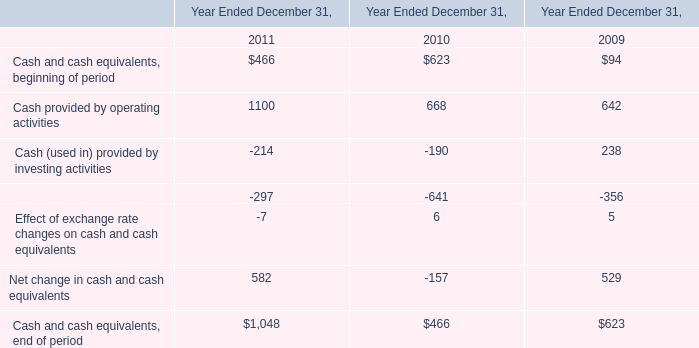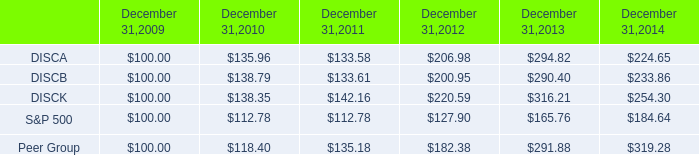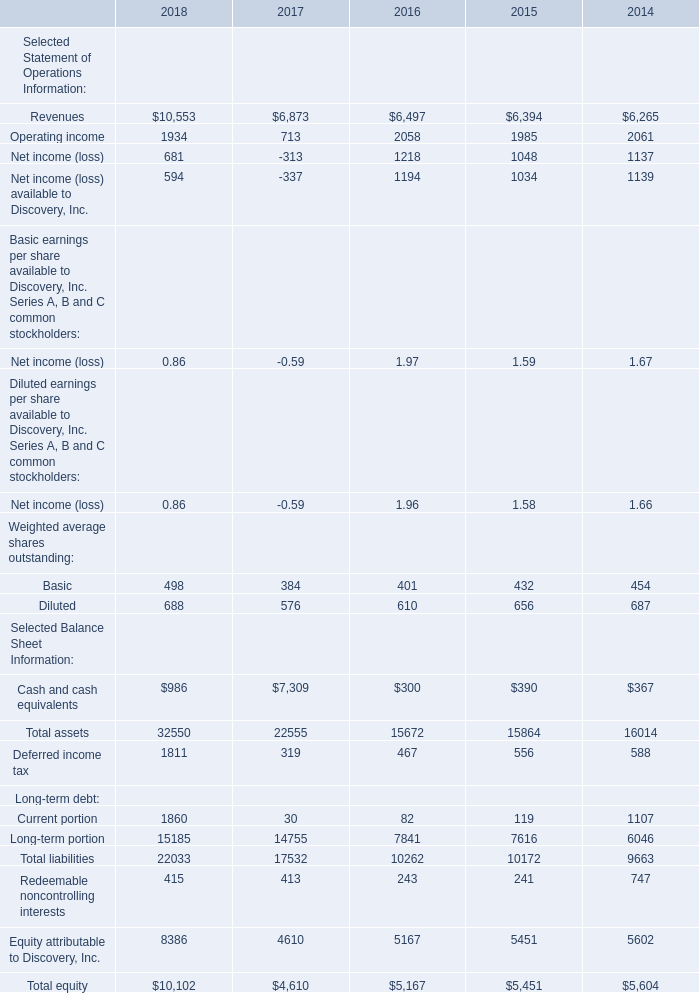what was the percentage cumulative total shareholder return on discb common stock for the five year period ended december 31 , 2014? 
Computations: ((233.86 - 100) / 100)
Answer: 1.3386. 